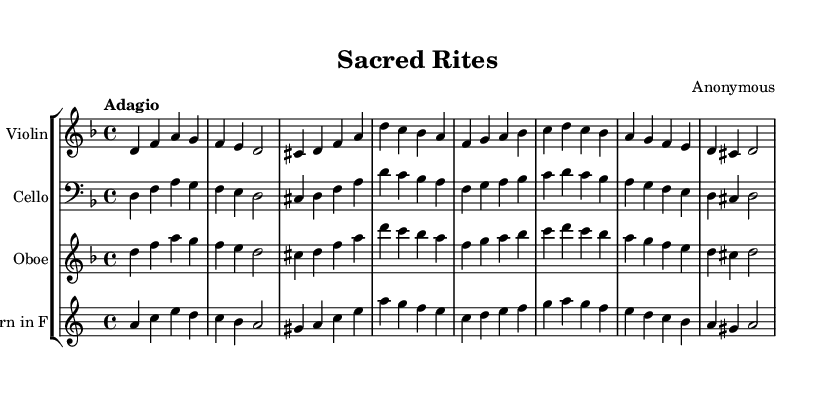What is the key signature of this music? The key signature is indicated at the beginning of the music. In this case, it shows one flat (B♭), which corresponds to D minor.
Answer: D minor What is the time signature of this music? The time signature appears at the beginning of the music, represented in a fraction format. Here, it shows a 4 over 4, indicating that there are four beats in each measure and each beat is a quarter note.
Answer: 4/4 What is the tempo marking for this composition? The tempo marking is shown above the staff and indicates how fast or slow the piece should be played. In this case, it indicates "Adagio," which means to play slowly.
Answer: Adagio How many instruments are featured in this piece? The number of instruments is indicated by the number of staves in the score. Here, there are four distinct staves corresponding to four instruments: Violin, Cello, Oboe, and Horn in F.
Answer: Four Which instruments share the same melodic line in this piece? To determine instruments with the same melodic line, we observe the music written in the staves. The Violin, Cello, and Oboe all have the same melodic lines displayed on their respective staves.
Answer: Violin, Cello, and Oboe What is the final note of the composition? To find the final note, we look at the last measure of the sheet music. The last note shown in the composition is D, as indicated in the notation.
Answer: D 